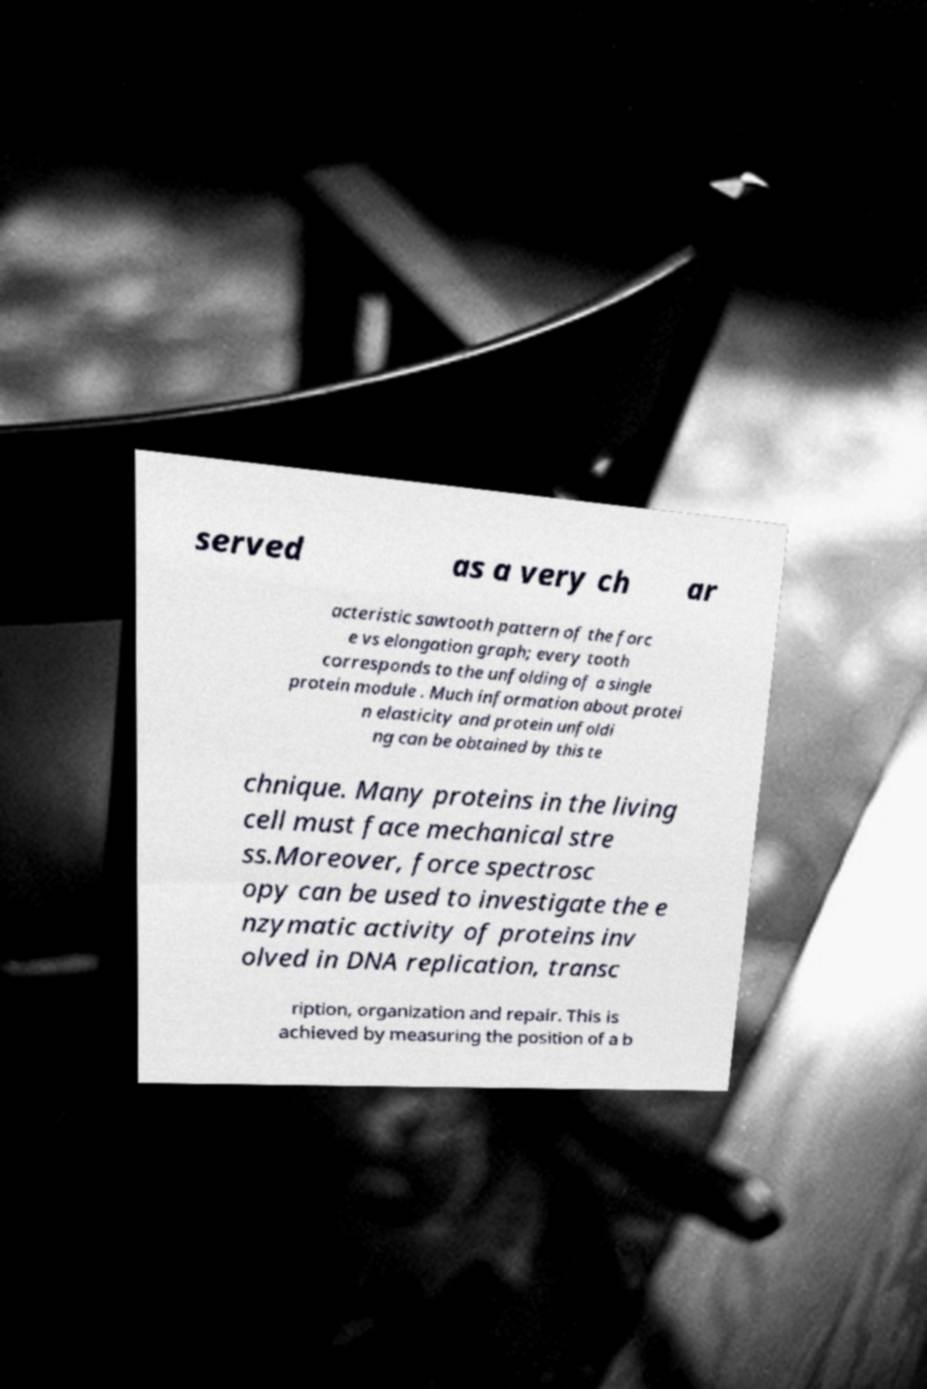Could you extract and type out the text from this image? served as a very ch ar acteristic sawtooth pattern of the forc e vs elongation graph; every tooth corresponds to the unfolding of a single protein module . Much information about protei n elasticity and protein unfoldi ng can be obtained by this te chnique. Many proteins in the living cell must face mechanical stre ss.Moreover, force spectrosc opy can be used to investigate the e nzymatic activity of proteins inv olved in DNA replication, transc ription, organization and repair. This is achieved by measuring the position of a b 